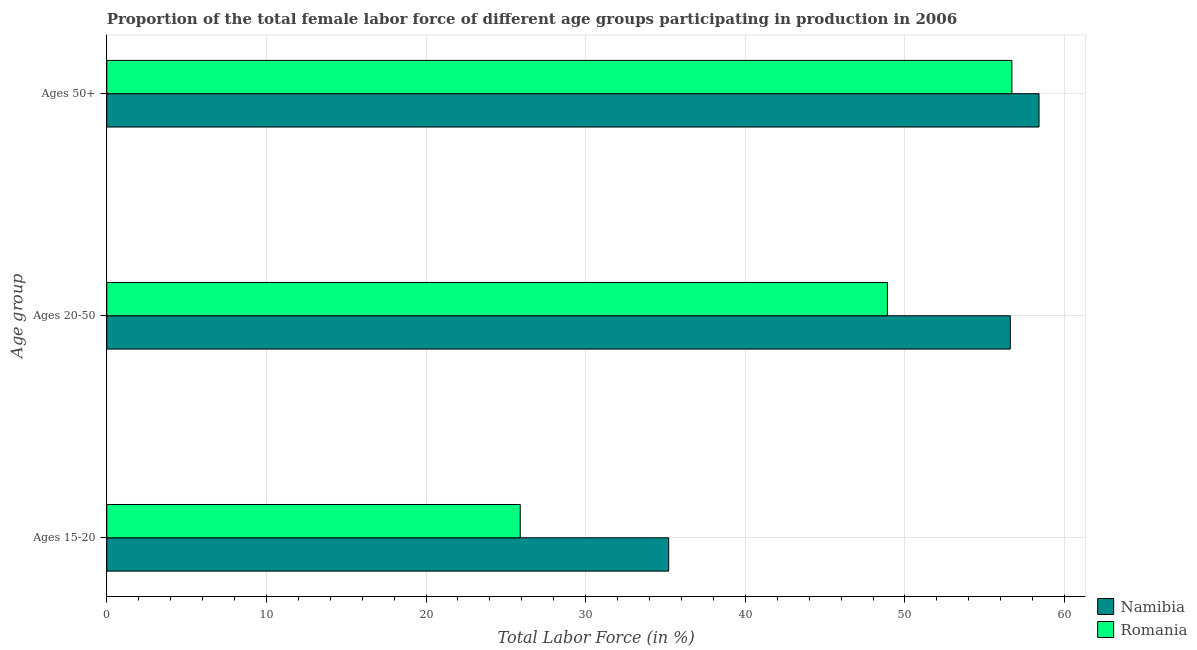How many groups of bars are there?
Your response must be concise. 3. Are the number of bars per tick equal to the number of legend labels?
Give a very brief answer. Yes. How many bars are there on the 3rd tick from the bottom?
Your answer should be very brief. 2. What is the label of the 3rd group of bars from the top?
Provide a succinct answer. Ages 15-20. What is the percentage of female labor force above age 50 in Romania?
Offer a very short reply. 56.7. Across all countries, what is the maximum percentage of female labor force within the age group 15-20?
Make the answer very short. 35.2. Across all countries, what is the minimum percentage of female labor force above age 50?
Ensure brevity in your answer.  56.7. In which country was the percentage of female labor force within the age group 20-50 maximum?
Give a very brief answer. Namibia. In which country was the percentage of female labor force within the age group 15-20 minimum?
Make the answer very short. Romania. What is the total percentage of female labor force within the age group 15-20 in the graph?
Your answer should be compact. 61.1. What is the difference between the percentage of female labor force above age 50 in Romania and that in Namibia?
Your answer should be compact. -1.7. What is the average percentage of female labor force above age 50 per country?
Ensure brevity in your answer.  57.55. What is the difference between the percentage of female labor force above age 50 and percentage of female labor force within the age group 15-20 in Namibia?
Make the answer very short. 23.2. What is the ratio of the percentage of female labor force within the age group 20-50 in Romania to that in Namibia?
Ensure brevity in your answer.  0.86. Is the percentage of female labor force within the age group 20-50 in Romania less than that in Namibia?
Keep it short and to the point. Yes. Is the difference between the percentage of female labor force within the age group 15-20 in Namibia and Romania greater than the difference between the percentage of female labor force above age 50 in Namibia and Romania?
Provide a succinct answer. Yes. What is the difference between the highest and the second highest percentage of female labor force within the age group 15-20?
Your response must be concise. 9.3. What is the difference between the highest and the lowest percentage of female labor force above age 50?
Provide a short and direct response. 1.7. In how many countries, is the percentage of female labor force within the age group 20-50 greater than the average percentage of female labor force within the age group 20-50 taken over all countries?
Provide a succinct answer. 1. What does the 1st bar from the top in Ages 15-20 represents?
Provide a short and direct response. Romania. What does the 1st bar from the bottom in Ages 50+ represents?
Provide a succinct answer. Namibia. How many legend labels are there?
Keep it short and to the point. 2. What is the title of the graph?
Offer a terse response. Proportion of the total female labor force of different age groups participating in production in 2006. Does "Canada" appear as one of the legend labels in the graph?
Your response must be concise. No. What is the label or title of the X-axis?
Give a very brief answer. Total Labor Force (in %). What is the label or title of the Y-axis?
Your answer should be very brief. Age group. What is the Total Labor Force (in %) in Namibia in Ages 15-20?
Your answer should be compact. 35.2. What is the Total Labor Force (in %) of Romania in Ages 15-20?
Your answer should be compact. 25.9. What is the Total Labor Force (in %) in Namibia in Ages 20-50?
Ensure brevity in your answer.  56.6. What is the Total Labor Force (in %) of Romania in Ages 20-50?
Ensure brevity in your answer.  48.9. What is the Total Labor Force (in %) in Namibia in Ages 50+?
Offer a very short reply. 58.4. What is the Total Labor Force (in %) of Romania in Ages 50+?
Your answer should be very brief. 56.7. Across all Age group, what is the maximum Total Labor Force (in %) of Namibia?
Keep it short and to the point. 58.4. Across all Age group, what is the maximum Total Labor Force (in %) in Romania?
Your answer should be compact. 56.7. Across all Age group, what is the minimum Total Labor Force (in %) of Namibia?
Your answer should be very brief. 35.2. Across all Age group, what is the minimum Total Labor Force (in %) of Romania?
Provide a succinct answer. 25.9. What is the total Total Labor Force (in %) in Namibia in the graph?
Keep it short and to the point. 150.2. What is the total Total Labor Force (in %) in Romania in the graph?
Your response must be concise. 131.5. What is the difference between the Total Labor Force (in %) in Namibia in Ages 15-20 and that in Ages 20-50?
Keep it short and to the point. -21.4. What is the difference between the Total Labor Force (in %) in Romania in Ages 15-20 and that in Ages 20-50?
Provide a succinct answer. -23. What is the difference between the Total Labor Force (in %) in Namibia in Ages 15-20 and that in Ages 50+?
Make the answer very short. -23.2. What is the difference between the Total Labor Force (in %) in Romania in Ages 15-20 and that in Ages 50+?
Your answer should be compact. -30.8. What is the difference between the Total Labor Force (in %) of Namibia in Ages 20-50 and that in Ages 50+?
Your answer should be compact. -1.8. What is the difference between the Total Labor Force (in %) in Namibia in Ages 15-20 and the Total Labor Force (in %) in Romania in Ages 20-50?
Make the answer very short. -13.7. What is the difference between the Total Labor Force (in %) in Namibia in Ages 15-20 and the Total Labor Force (in %) in Romania in Ages 50+?
Offer a very short reply. -21.5. What is the difference between the Total Labor Force (in %) in Namibia in Ages 20-50 and the Total Labor Force (in %) in Romania in Ages 50+?
Keep it short and to the point. -0.1. What is the average Total Labor Force (in %) of Namibia per Age group?
Your answer should be very brief. 50.07. What is the average Total Labor Force (in %) of Romania per Age group?
Keep it short and to the point. 43.83. What is the difference between the Total Labor Force (in %) of Namibia and Total Labor Force (in %) of Romania in Ages 20-50?
Provide a succinct answer. 7.7. What is the difference between the Total Labor Force (in %) in Namibia and Total Labor Force (in %) in Romania in Ages 50+?
Provide a short and direct response. 1.7. What is the ratio of the Total Labor Force (in %) in Namibia in Ages 15-20 to that in Ages 20-50?
Offer a terse response. 0.62. What is the ratio of the Total Labor Force (in %) of Romania in Ages 15-20 to that in Ages 20-50?
Provide a succinct answer. 0.53. What is the ratio of the Total Labor Force (in %) in Namibia in Ages 15-20 to that in Ages 50+?
Offer a terse response. 0.6. What is the ratio of the Total Labor Force (in %) in Romania in Ages 15-20 to that in Ages 50+?
Make the answer very short. 0.46. What is the ratio of the Total Labor Force (in %) in Namibia in Ages 20-50 to that in Ages 50+?
Your answer should be compact. 0.97. What is the ratio of the Total Labor Force (in %) of Romania in Ages 20-50 to that in Ages 50+?
Your answer should be very brief. 0.86. What is the difference between the highest and the second highest Total Labor Force (in %) in Namibia?
Provide a short and direct response. 1.8. What is the difference between the highest and the second highest Total Labor Force (in %) in Romania?
Your answer should be very brief. 7.8. What is the difference between the highest and the lowest Total Labor Force (in %) of Namibia?
Provide a succinct answer. 23.2. What is the difference between the highest and the lowest Total Labor Force (in %) in Romania?
Keep it short and to the point. 30.8. 